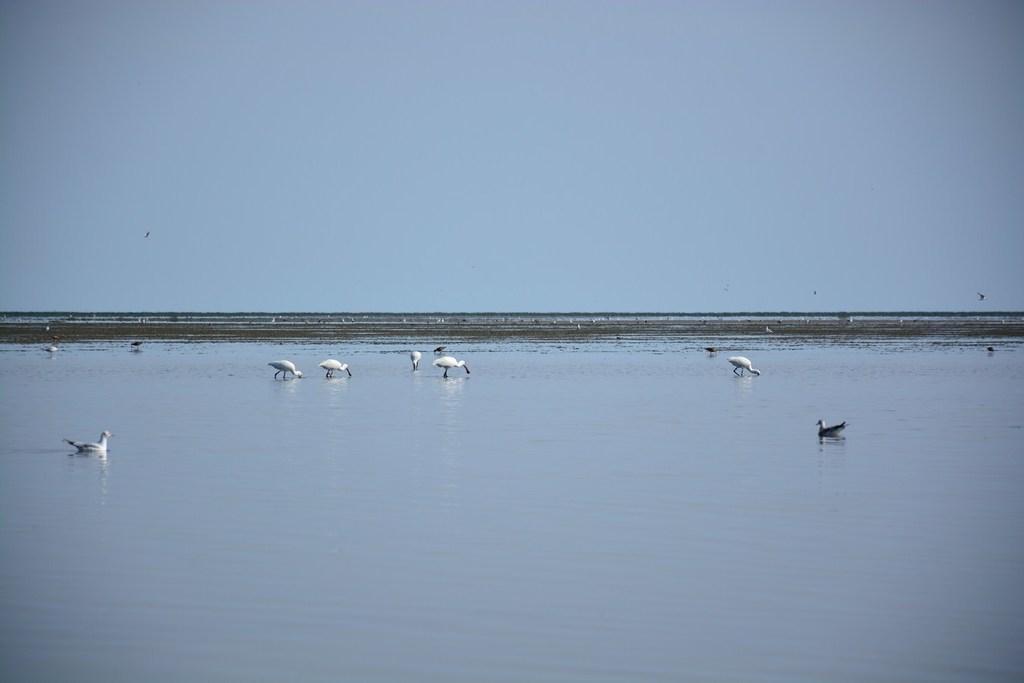Please provide a concise description of this image. In this image we can see the birds on the surface of the water. We can also see the soil and also the sky. 